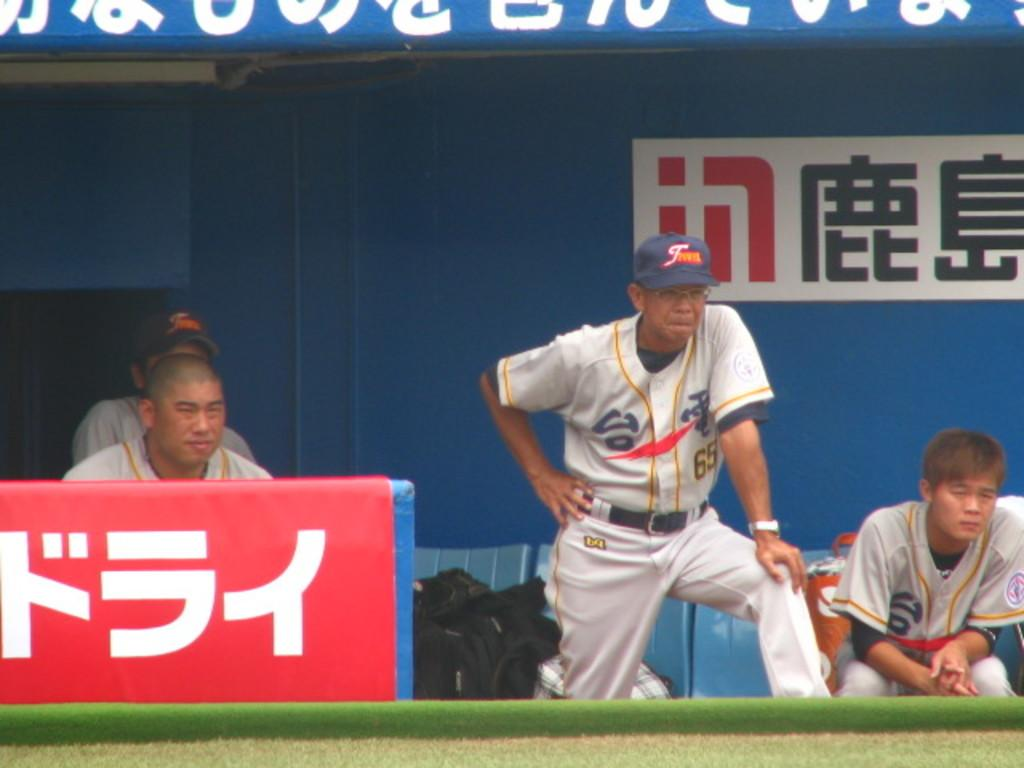Provide a one-sentence caption for the provided image. Japanese baseball players watch the game from the dugout. 